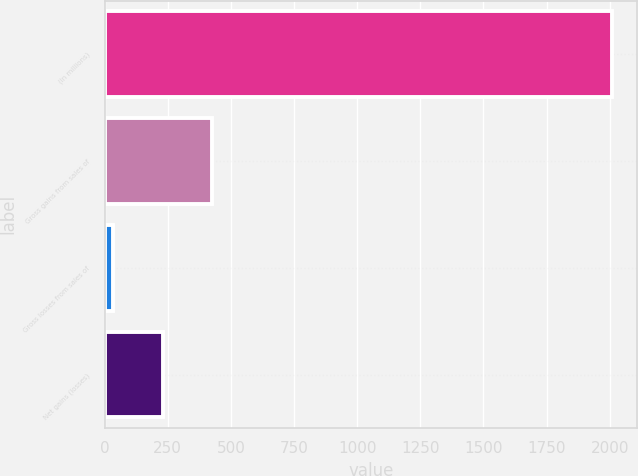Convert chart to OTSL. <chart><loc_0><loc_0><loc_500><loc_500><bar_chart><fcel>(In millions)<fcel>Gross gains from sales of<fcel>Gross losses from sales of<fcel>Net gains (losses)<nl><fcel>2008<fcel>427.2<fcel>32<fcel>229.6<nl></chart> 